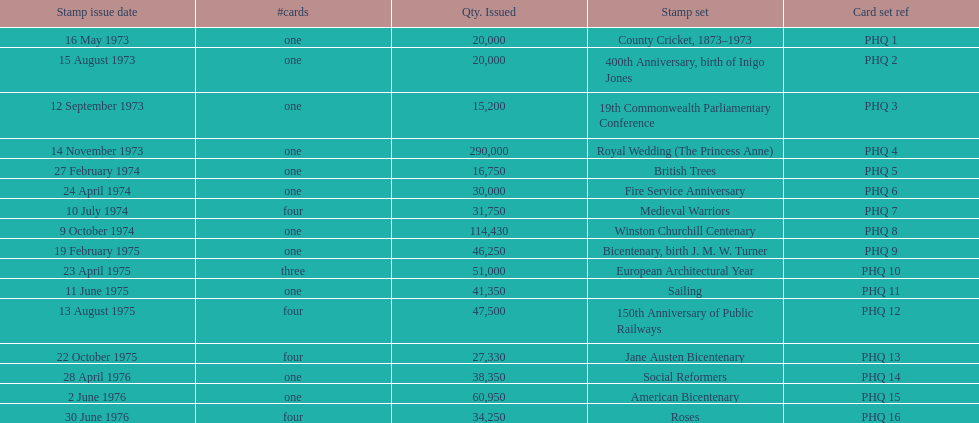Give me the full table as a dictionary. {'header': ['Stamp issue date', '#cards', 'Qty. Issued', 'Stamp set', 'Card set ref'], 'rows': [['16 May 1973', 'one', '20,000', 'County Cricket, 1873–1973', 'PHQ 1'], ['15 August 1973', 'one', '20,000', '400th Anniversary, birth of Inigo Jones', 'PHQ 2'], ['12 September 1973', 'one', '15,200', '19th Commonwealth Parliamentary Conference', 'PHQ 3'], ['14 November 1973', 'one', '290,000', 'Royal Wedding (The Princess Anne)', 'PHQ 4'], ['27 February 1974', 'one', '16,750', 'British Trees', 'PHQ 5'], ['24 April 1974', 'one', '30,000', 'Fire Service Anniversary', 'PHQ 6'], ['10 July 1974', 'four', '31,750', 'Medieval Warriors', 'PHQ 7'], ['9 October 1974', 'one', '114,430', 'Winston Churchill Centenary', 'PHQ 8'], ['19 February 1975', 'one', '46,250', 'Bicentenary, birth J. M. W. Turner', 'PHQ 9'], ['23 April 1975', 'three', '51,000', 'European Architectural Year', 'PHQ 10'], ['11 June 1975', 'one', '41,350', 'Sailing', 'PHQ 11'], ['13 August 1975', 'four', '47,500', '150th Anniversary of Public Railways', 'PHQ 12'], ['22 October 1975', 'four', '27,330', 'Jane Austen Bicentenary', 'PHQ 13'], ['28 April 1976', 'one', '38,350', 'Social Reformers', 'PHQ 14'], ['2 June 1976', 'one', '60,950', 'American Bicentenary', 'PHQ 15'], ['30 June 1976', 'four', '34,250', 'Roses', 'PHQ 16']]} How many stamp sets were released in the year 1975? 5. 